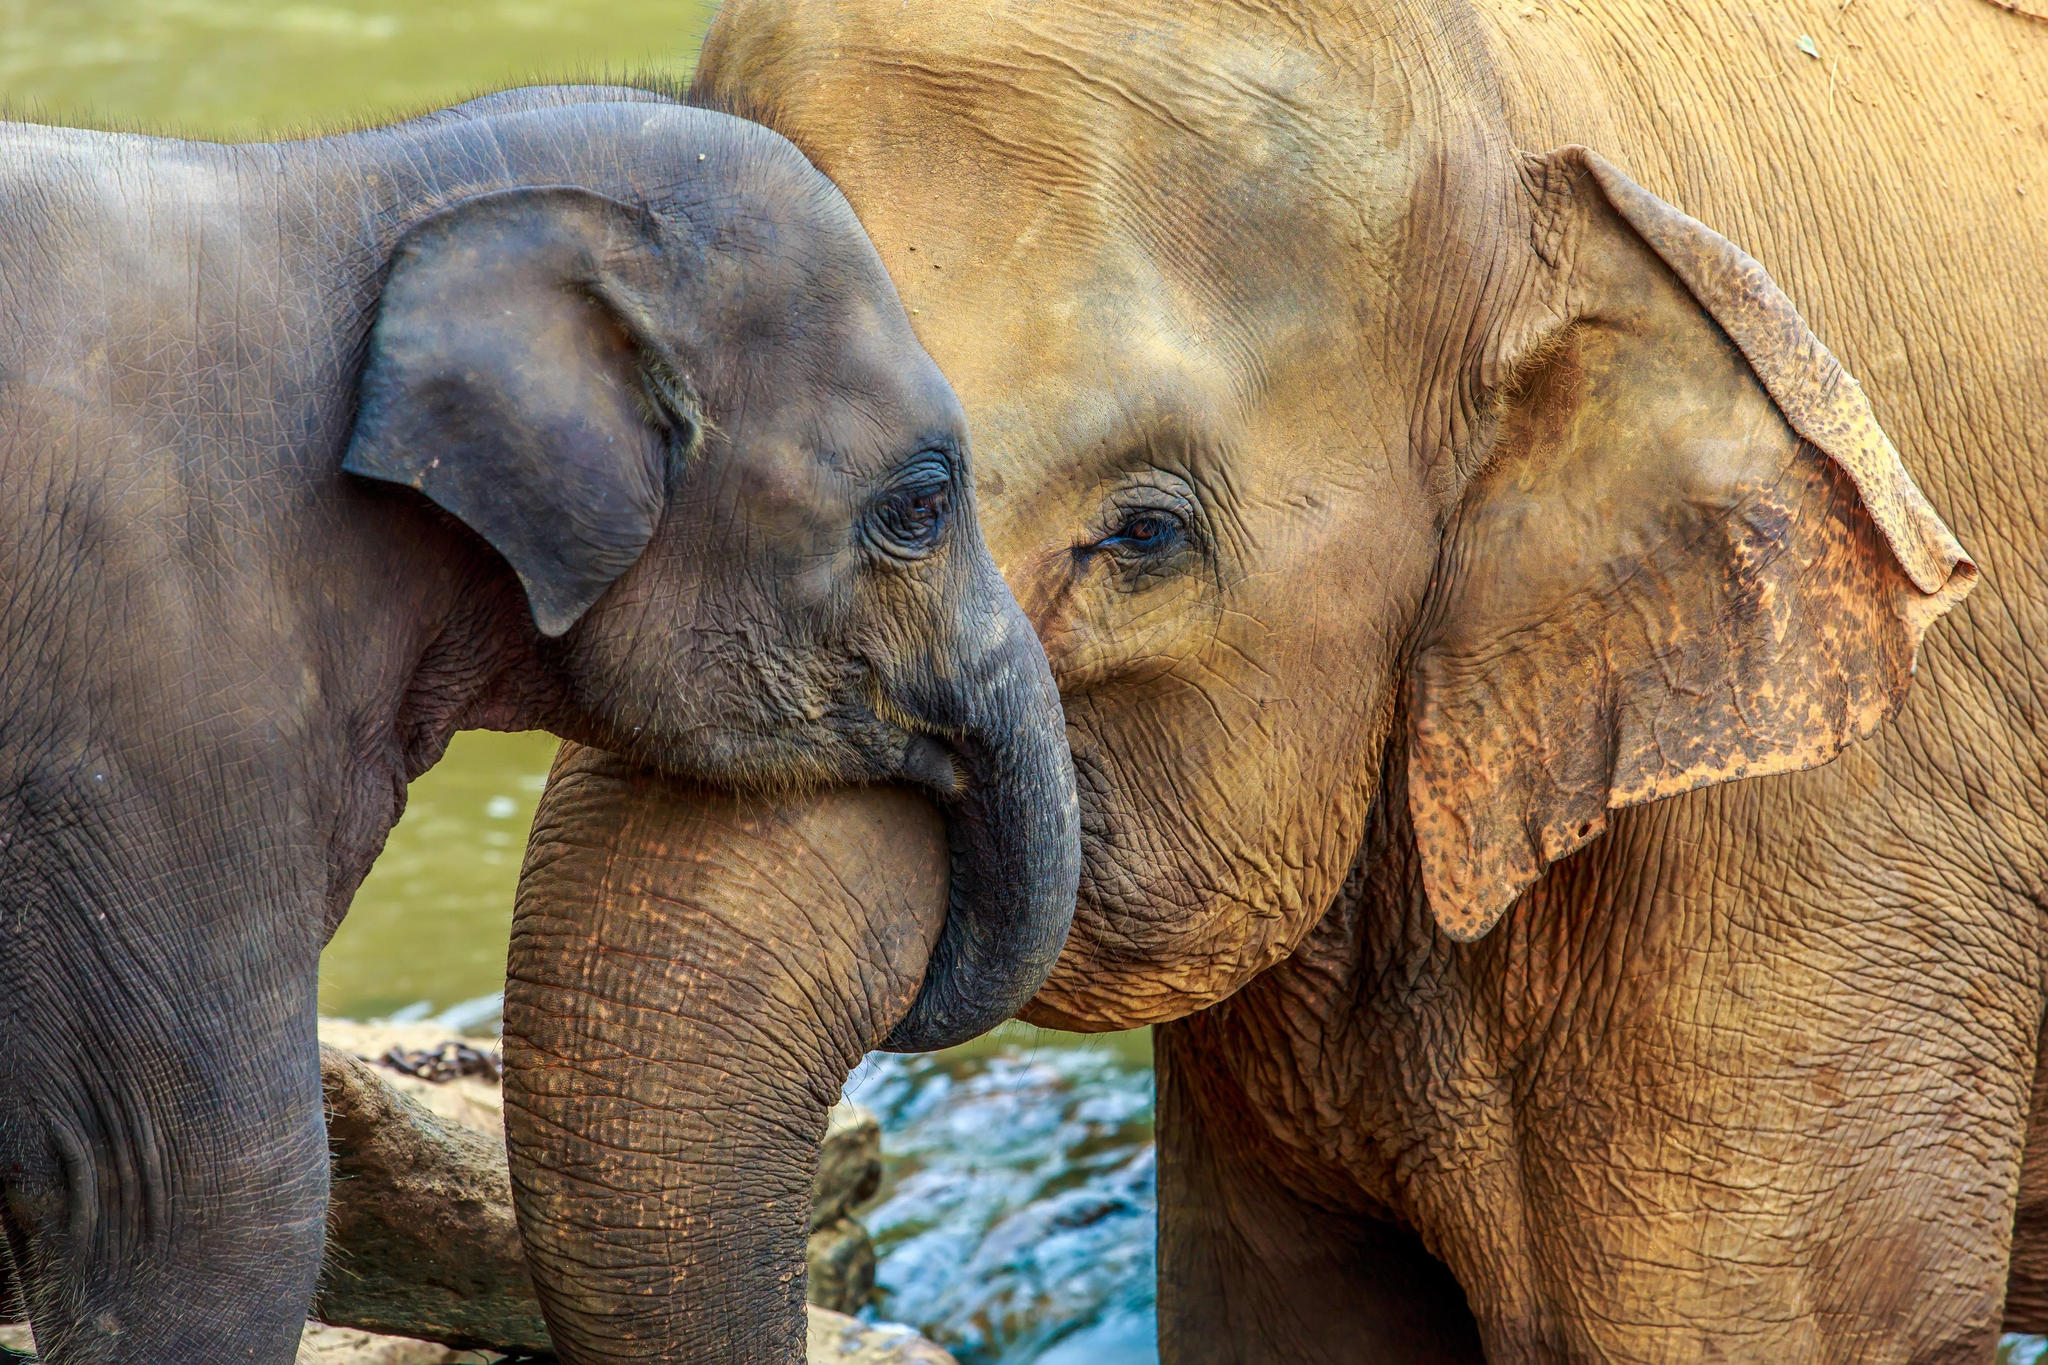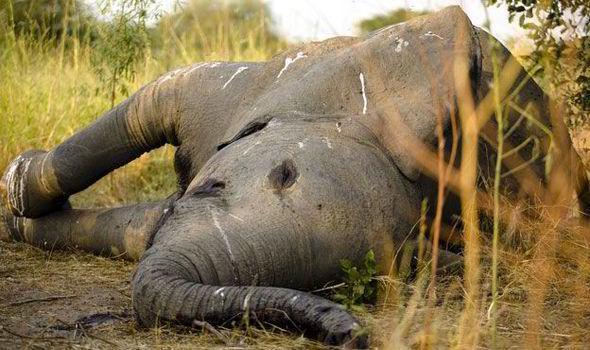The first image is the image on the left, the second image is the image on the right. For the images shown, is this caption "There are at most 3 elephants in the pair of images." true? Answer yes or no. Yes. 